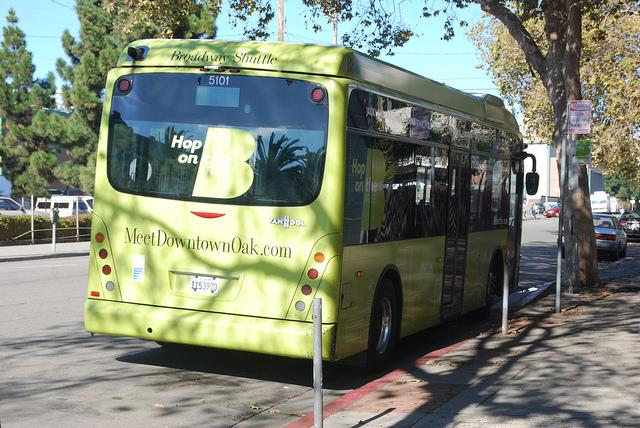What city is this? Please explain your reasoning. oakland. A city bus has logos on the back of it mentioning "oak". 